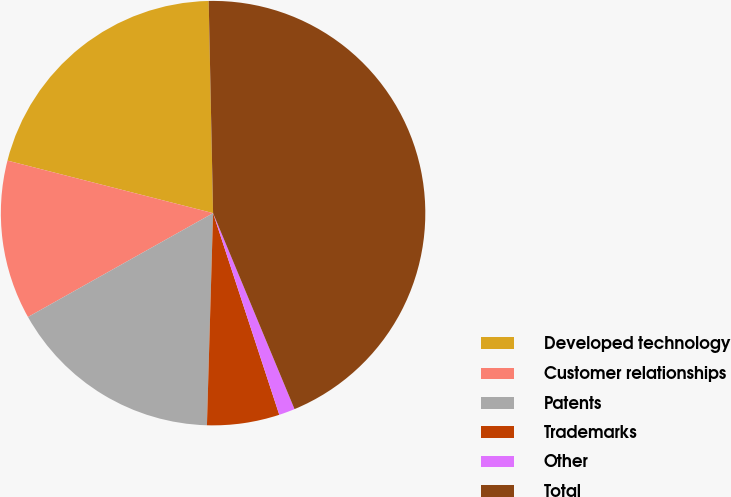Convert chart to OTSL. <chart><loc_0><loc_0><loc_500><loc_500><pie_chart><fcel>Developed technology<fcel>Customer relationships<fcel>Patents<fcel>Trademarks<fcel>Other<fcel>Total<nl><fcel>20.69%<fcel>12.12%<fcel>16.4%<fcel>5.51%<fcel>1.22%<fcel>44.06%<nl></chart> 